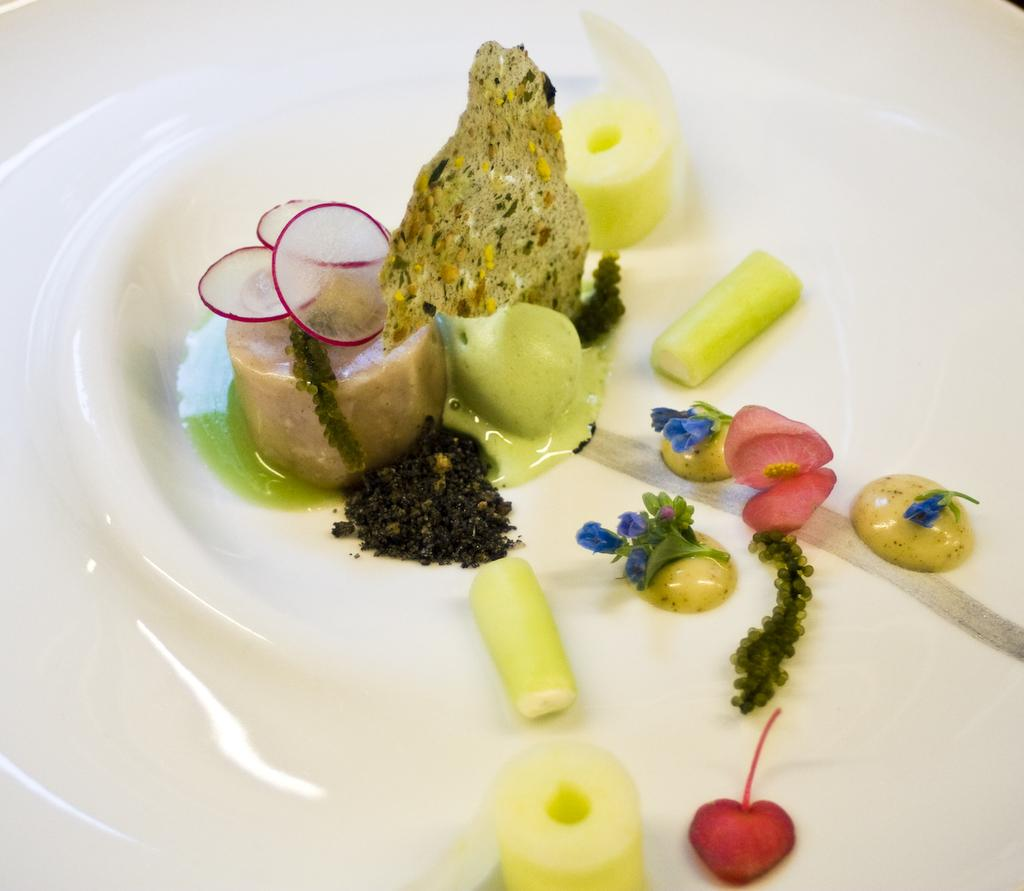What is on the plate that is visible in the image? There is food placed on a plate in the image. Where is the plate located in the image? The plate is located in the center of the image. What type of company is mentioned in the image? There is no company mentioned in the image; it only shows a plate with food on it. 